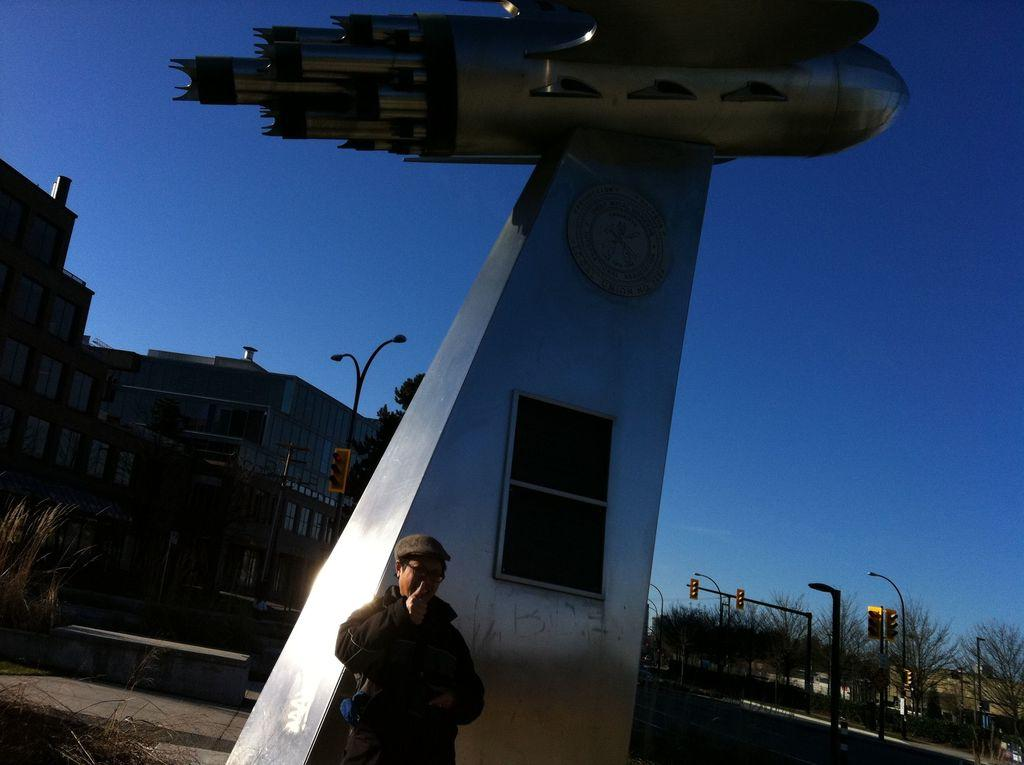What is the main subject in the image? There is a person standing in the image. What can be seen in the foreground of the image? There is a model of an aircraft in the foreground of the image. What is visible in the background of the image? There are poles, trees, buildings, and the sky visible in the background of the image. How many plastic clovers are scattered around the person in the image? There are no plastic clovers present in the image. How many houses can be seen in the background of the image? The image does not show any houses in the background; it only shows poles, trees, buildings, and the sky. 